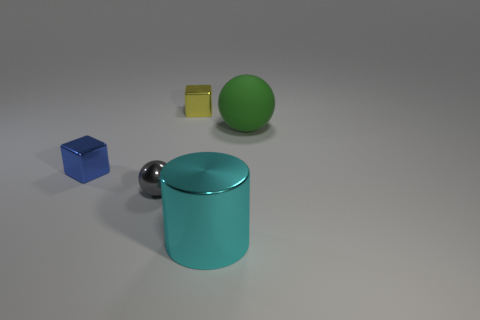What color is the sphere in front of the green matte sphere?
Make the answer very short. Gray. Is there a tiny cube of the same color as the cylinder?
Make the answer very short. No. There is a thing that is the same size as the green rubber sphere; what is its color?
Offer a terse response. Cyan. Does the small gray thing have the same shape as the large green matte thing?
Make the answer very short. Yes. What material is the ball left of the shiny cylinder?
Keep it short and to the point. Metal. What color is the small metal sphere?
Give a very brief answer. Gray. Does the ball that is to the left of the rubber sphere have the same size as the sphere that is right of the tiny gray metal ball?
Provide a succinct answer. No. There is a object that is to the right of the small yellow thing and to the left of the big green object; how big is it?
Provide a succinct answer. Large. What color is the other small thing that is the same shape as the yellow thing?
Your answer should be compact. Blue. Are there more small blue objects to the left of the cyan metallic thing than metal spheres on the left side of the tiny gray object?
Give a very brief answer. Yes. 